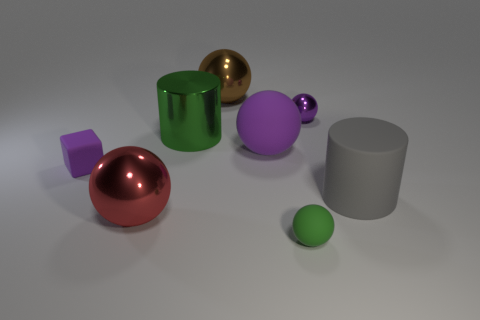What is the shape of the matte thing that is the same color as the big matte sphere?
Provide a succinct answer. Cube. There is a green object in front of the rubber cylinder; is its shape the same as the tiny shiny object?
Give a very brief answer. Yes. What is the small purple object that is on the right side of the brown thing made of?
Give a very brief answer. Metal. The tiny matte object left of the rubber ball behind the large red shiny sphere is what shape?
Offer a very short reply. Cube. There is a red object; is its shape the same as the tiny matte thing left of the red sphere?
Your answer should be very brief. No. There is a shiny thing that is to the right of the brown sphere; what number of tiny purple objects are in front of it?
Make the answer very short. 1. There is a large green thing that is the same shape as the big gray rubber thing; what is it made of?
Ensure brevity in your answer.  Metal. What number of purple things are either tiny cubes or balls?
Provide a succinct answer. 3. Is there any other thing of the same color as the small block?
Offer a terse response. Yes. What color is the rubber sphere that is behind the matte ball in front of the large gray rubber thing?
Your response must be concise. Purple. 